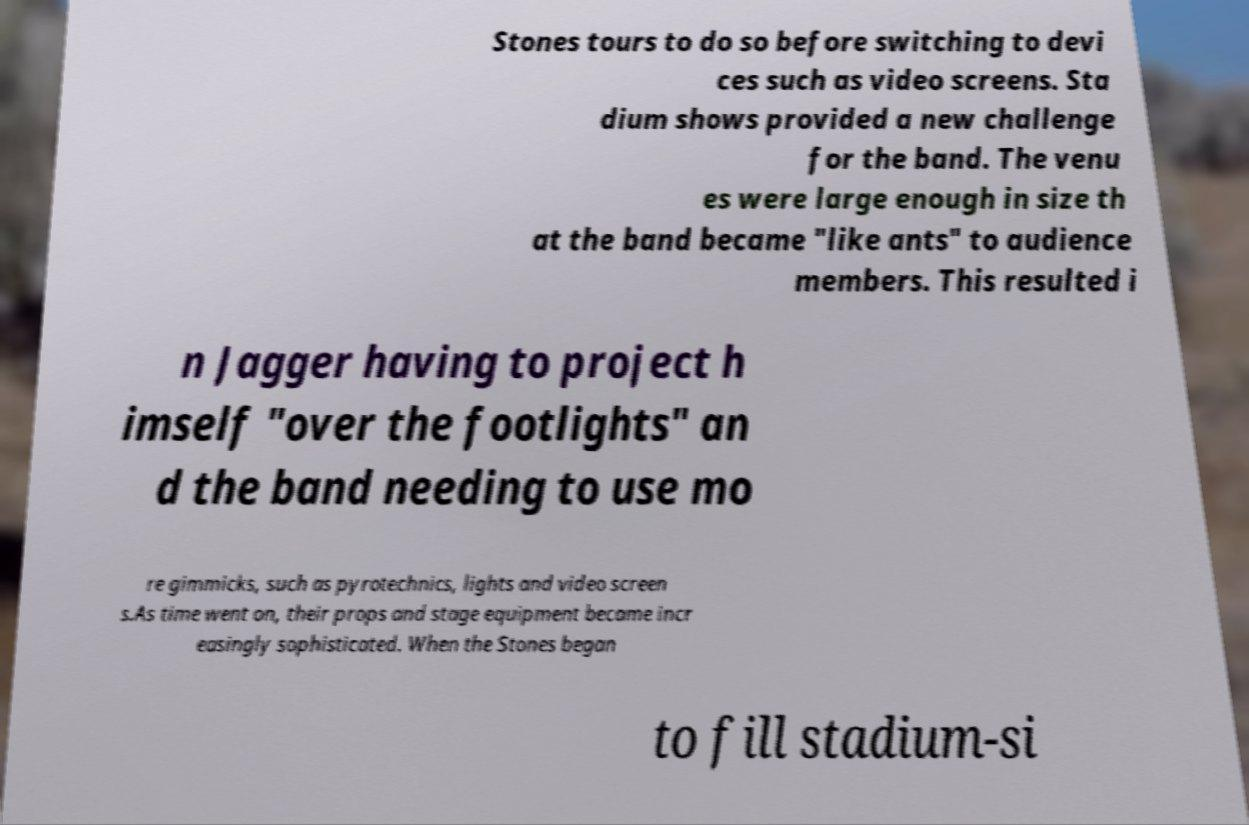I need the written content from this picture converted into text. Can you do that? Stones tours to do so before switching to devi ces such as video screens. Sta dium shows provided a new challenge for the band. The venu es were large enough in size th at the band became "like ants" to audience members. This resulted i n Jagger having to project h imself "over the footlights" an d the band needing to use mo re gimmicks, such as pyrotechnics, lights and video screen s.As time went on, their props and stage equipment became incr easingly sophisticated. When the Stones began to fill stadium-si 